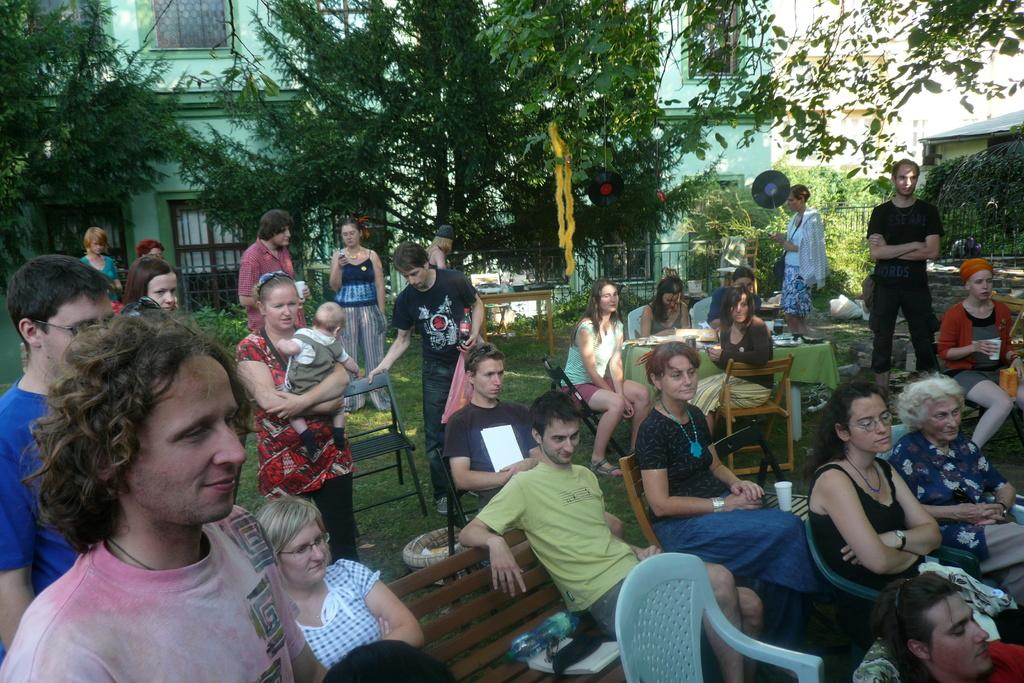What are the people in the image doing? The people in the image are sitting and standing. Where is the scene taking place? The setting is a garden. What type of vegetation can be seen in the image? There are trees in the image. What structure is visible in the background? There is a building in the image. What type of dust can be seen on the leaves of the trees in the image? There is no dust visible on the leaves of the trees in the image. How much money is being exchanged between the people in the image? There is no indication of money being exchanged between the people in the image. 